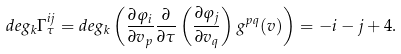<formula> <loc_0><loc_0><loc_500><loc_500>d e g _ { k } \Gamma _ { \tau } ^ { i j } = d e g _ { k } \left ( \frac { \partial \varphi _ { i } } { \partial v _ { p } } \frac { \partial } { \partial \tau } \left ( \frac { \partial \varphi _ { j } } { \partial v _ { q } } \right ) g ^ { p q } ( v ) \right ) = - i - j + 4 .</formula> 